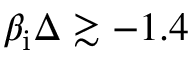<formula> <loc_0><loc_0><loc_500><loc_500>\beta _ { i } \Delta \gtrsim - 1 . 4</formula> 